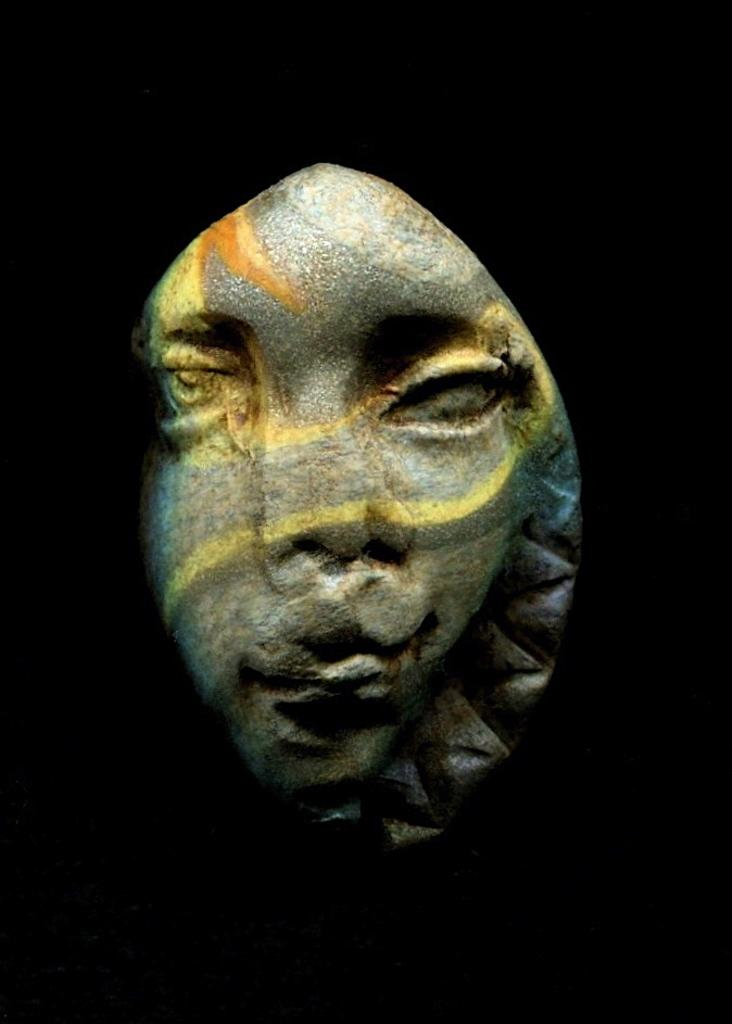What is the main subject of the image? There is a sculpture in the image. How is the sculpture being viewed in the image? The sculpture is visible through a hole. What type of plastic is used to create the stream in the image? There is no stream or plastic present in the image; it features a sculpture visible through a hole. 